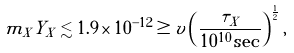Convert formula to latex. <formula><loc_0><loc_0><loc_500><loc_500>m _ { X } Y _ { X } \lesssim 1 . 9 \times 1 0 ^ { - 1 2 } \geq v \left ( \frac { \tau _ { X } } { 1 0 ^ { 1 0 } \sec } \right ) ^ { \frac { 1 } { 2 } } ,</formula> 